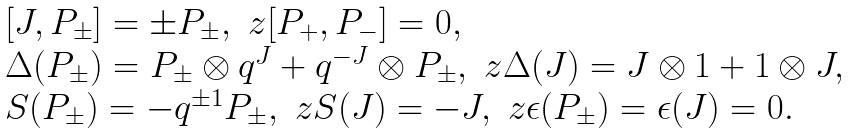Convert formula to latex. <formula><loc_0><loc_0><loc_500><loc_500>\begin{array} { l } [ J , P _ { \pm } ] = \pm P _ { \pm } , \ z [ P _ { + } , P _ { - } ] = 0 , \\ \Delta ( P _ { \pm } ) = P _ { \pm } \otimes q ^ { J } + q ^ { - J } \otimes P _ { \pm } , \ z \Delta ( J ) = J \otimes 1 + 1 \otimes J , \\ S ( P _ { \pm } ) = - q ^ { \pm 1 } P _ { \pm } , \ z S ( J ) = - J , \ z \epsilon ( P _ { \pm } ) = \epsilon ( J ) = 0 . \end{array}</formula> 